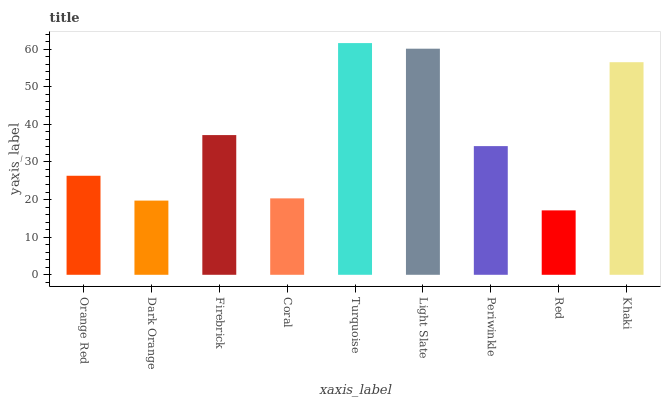Is Red the minimum?
Answer yes or no. Yes. Is Turquoise the maximum?
Answer yes or no. Yes. Is Dark Orange the minimum?
Answer yes or no. No. Is Dark Orange the maximum?
Answer yes or no. No. Is Orange Red greater than Dark Orange?
Answer yes or no. Yes. Is Dark Orange less than Orange Red?
Answer yes or no. Yes. Is Dark Orange greater than Orange Red?
Answer yes or no. No. Is Orange Red less than Dark Orange?
Answer yes or no. No. Is Periwinkle the high median?
Answer yes or no. Yes. Is Periwinkle the low median?
Answer yes or no. Yes. Is Turquoise the high median?
Answer yes or no. No. Is Khaki the low median?
Answer yes or no. No. 